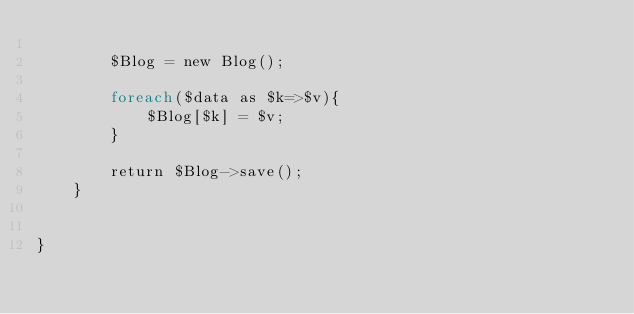<code> <loc_0><loc_0><loc_500><loc_500><_PHP_>
		$Blog = new Blog();

		foreach($data as $k=>$v){
			$Blog[$k] = $v;
		}

		return $Blog->save();
	}


}
</code> 